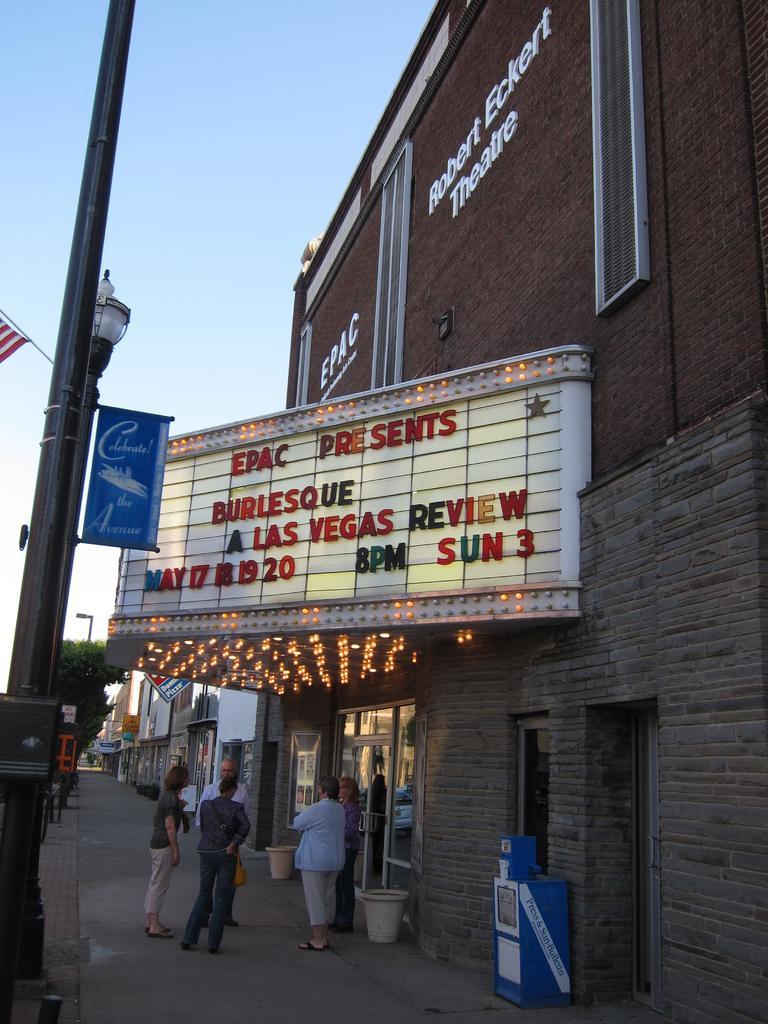In one or two sentences, can you explain what this image depicts? In this image I can see few buildings,glass doors,banners,poles,light poles,boards,lights and trees. The sky is in white and blue color. 